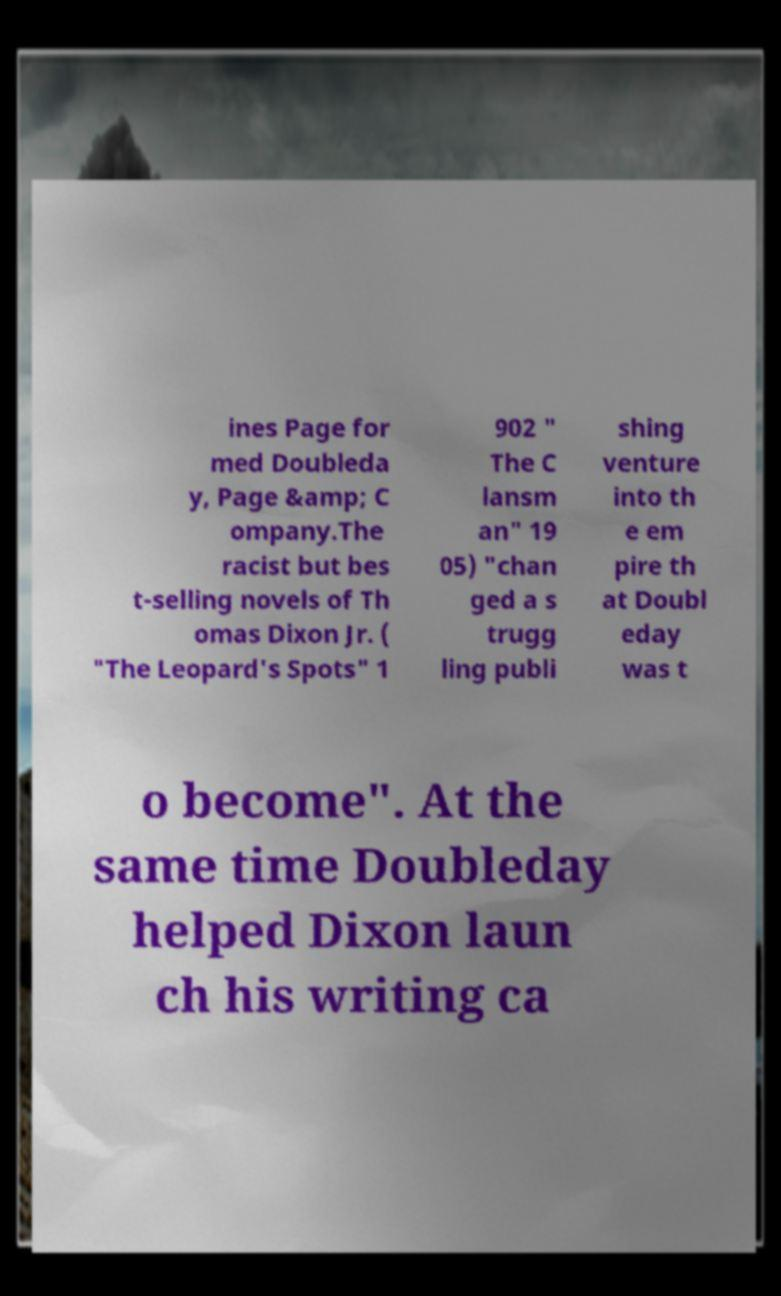Please identify and transcribe the text found in this image. ines Page for med Doubleda y, Page &amp; C ompany.The racist but bes t-selling novels of Th omas Dixon Jr. ( "The Leopard's Spots" 1 902 " The C lansm an" 19 05) "chan ged a s trugg ling publi shing venture into th e em pire th at Doubl eday was t o become". At the same time Doubleday helped Dixon laun ch his writing ca 